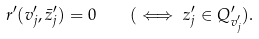<formula> <loc_0><loc_0><loc_500><loc_500>r ^ { \prime } ( v ^ { \prime } _ { j } , \bar { z } ^ { \prime } _ { j } ) = 0 \quad ( \iff z ^ { \prime } _ { j } \in Q ^ { \prime } _ { v ^ { \prime } _ { j } } ) .</formula> 